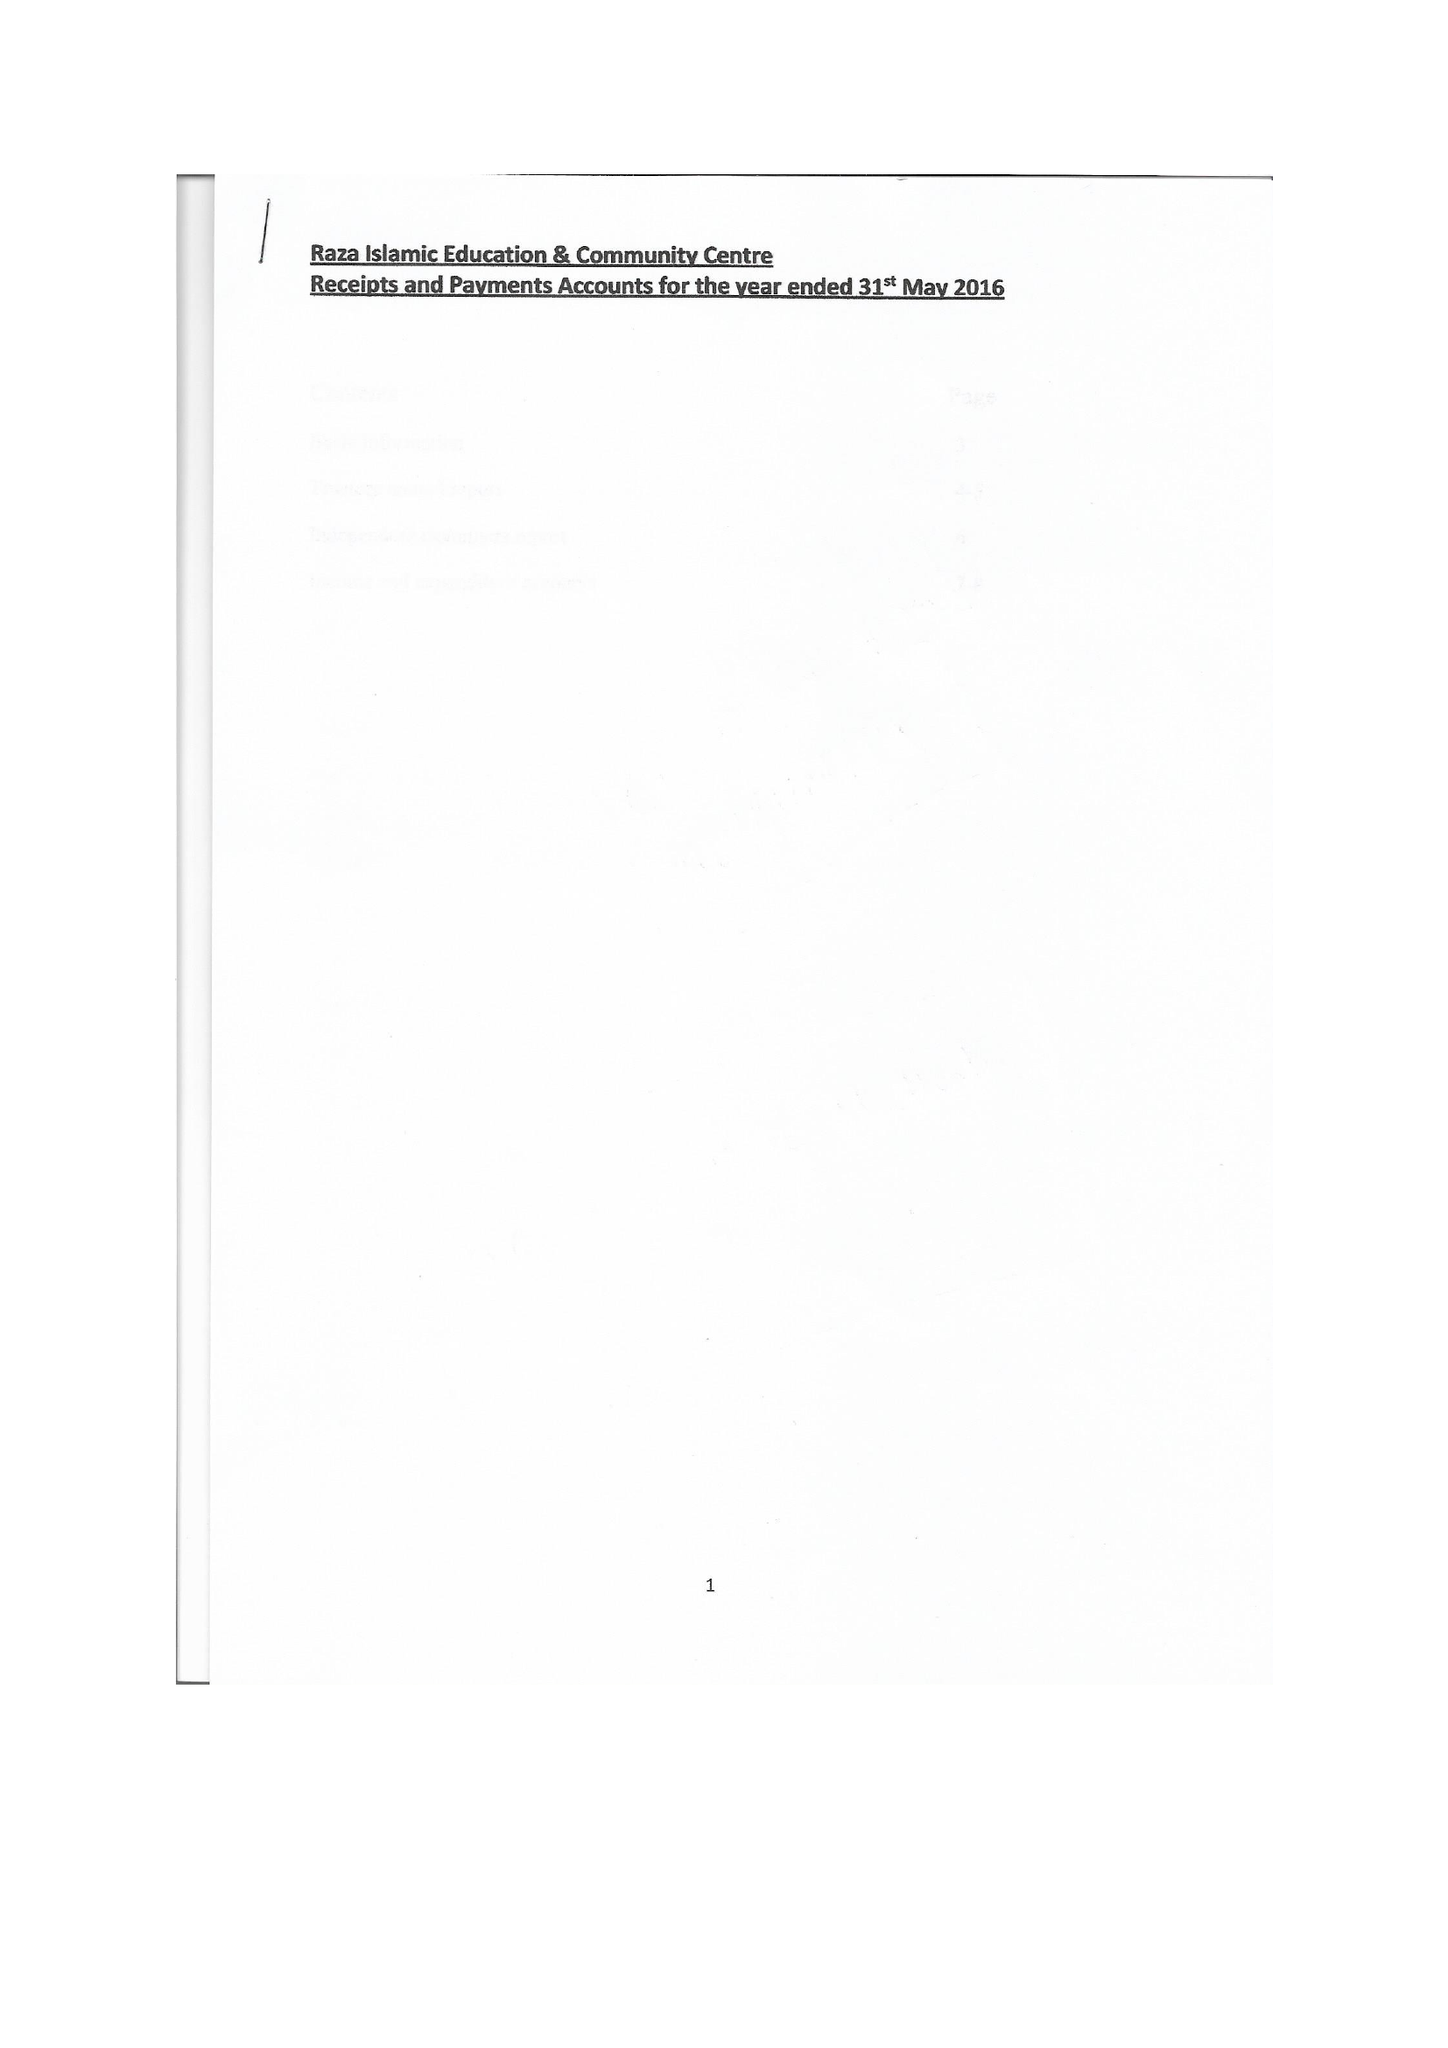What is the value for the report_date?
Answer the question using a single word or phrase. 2016-05-31 